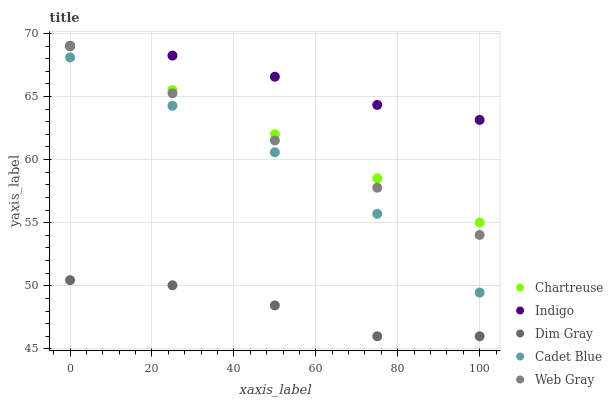Does Dim Gray have the minimum area under the curve?
Answer yes or no. Yes. Does Indigo have the maximum area under the curve?
Answer yes or no. Yes. Does Chartreuse have the minimum area under the curve?
Answer yes or no. No. Does Chartreuse have the maximum area under the curve?
Answer yes or no. No. Is Web Gray the smoothest?
Answer yes or no. Yes. Is Dim Gray the roughest?
Answer yes or no. Yes. Is Chartreuse the smoothest?
Answer yes or no. No. Is Chartreuse the roughest?
Answer yes or no. No. Does Dim Gray have the lowest value?
Answer yes or no. Yes. Does Chartreuse have the lowest value?
Answer yes or no. No. Does Web Gray have the highest value?
Answer yes or no. Yes. Does Dim Gray have the highest value?
Answer yes or no. No. Is Cadet Blue less than Indigo?
Answer yes or no. Yes. Is Web Gray greater than Dim Gray?
Answer yes or no. Yes. Does Indigo intersect Chartreuse?
Answer yes or no. Yes. Is Indigo less than Chartreuse?
Answer yes or no. No. Is Indigo greater than Chartreuse?
Answer yes or no. No. Does Cadet Blue intersect Indigo?
Answer yes or no. No. 